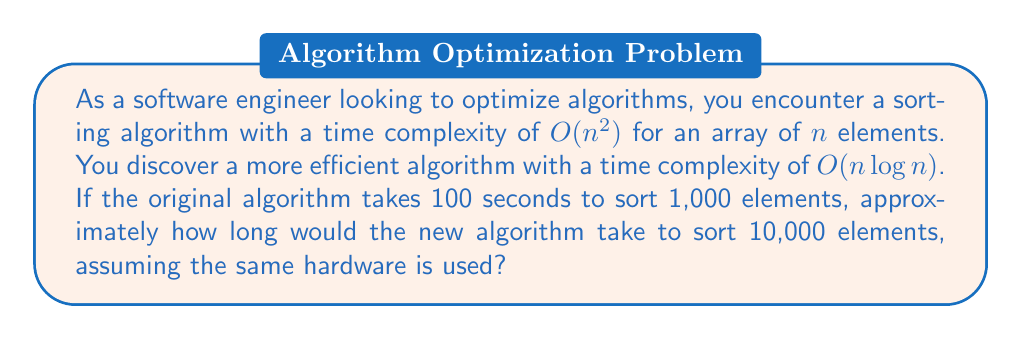What is the answer to this math problem? Let's approach this step-by-step:

1) First, we need to understand the relationship between the old and new algorithm for 1,000 elements:
   
   Old algorithm: $T_1(n) = cn^2$, where $c$ is a constant
   New algorithm: $T_2(n) = kn \log n$, where $k$ is a constant

2) We know that for $n = 1000$, $T_1(1000) = 100$ seconds
   
   $100 = c(1000)^2$
   $100 = c(1,000,000)$
   $c = 0.0000001$

3) Now, let's find $k$ using the same input size:
   
   $T_2(1000) = k(1000)(\log 1000)$
   $T_2(1000) = 1000k(3)$ (since $\log 1000 \approx 3$ in base 10)
   $T_2(1000) = 3000k$

4) We don't know the exact value of $T_2(1000)$, but we can express it in terms of $T_1(1000)$:
   
   $T_2(1000) = \frac{3000k}{100} \cdot T_1(1000) = 30k \cdot T_1(1000)$

5) Now, for $n = 10000$:
   
   $T_2(10000) = k(10000)(\log 10000)$
   $T_2(10000) = 10000k(4)$ (since $\log 10000 = 4$ in base 10)
   $T_2(10000) = 40000k$

6) Substituting $k$ from step 4:
   
   $T_2(10000) = 40000 \cdot \frac{T_2(1000)}{3000} = \frac{40}{3} \cdot T_2(1000)$

7) From step 4, we can say $T_2(1000) = 30k \cdot 100 = 3000k$

8) Therefore:
   
   $T_2(10000) = \frac{40}{3} \cdot 3000k = 40000k$

9) This is equivalent to $\frac{40}{3} \cdot T_2(1000) \approx 13.33 \cdot T_2(1000)$

Thus, the new algorithm would take approximately 13.33 times as long to sort 10,000 elements as it does to sort 1,000 elements.
Answer: $\approx 13.33 \cdot T_2(1000)$ seconds 